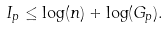Convert formula to latex. <formula><loc_0><loc_0><loc_500><loc_500>I _ { p } \leq \log ( n ) + \log ( G _ { p } ) .</formula> 